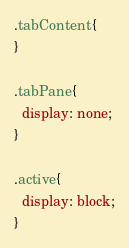<code> <loc_0><loc_0><loc_500><loc_500><_CSS_>.tabContent{
}

.tabPane{
  display: none;
}

.active{
  display: block;
}</code> 